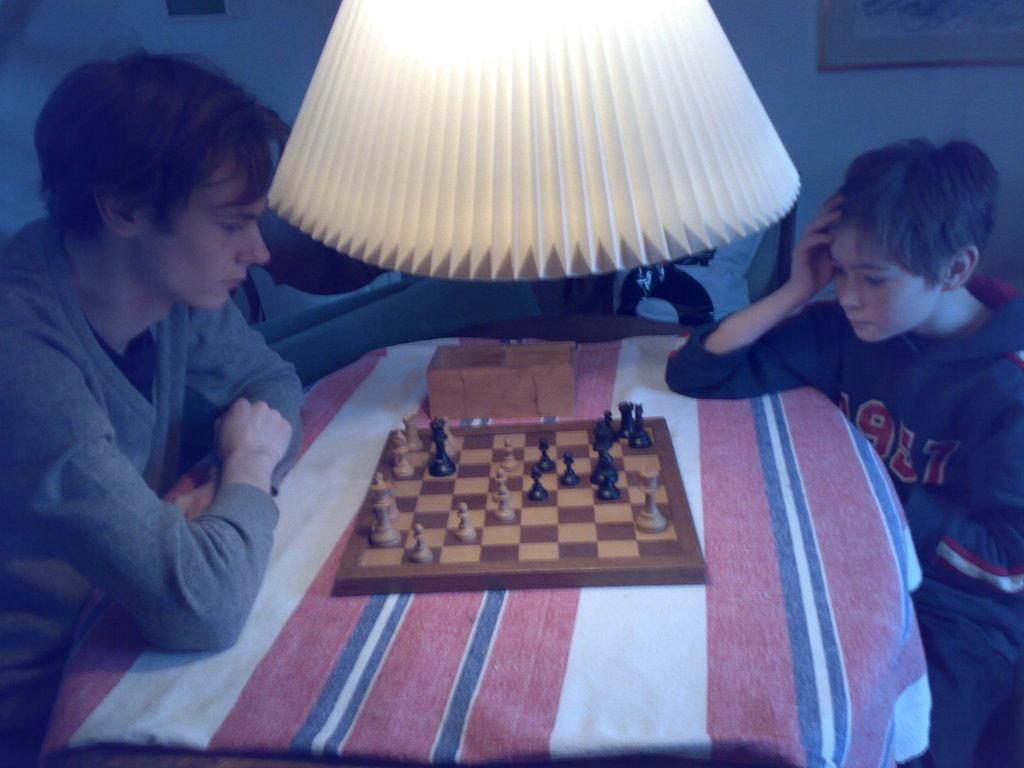How many people are in the image? There are two people in the image. What are the people doing in the image? The people are sitting on chairs. What is on the table in the image? There is a chess board, a small box, and a lamp on the table. What type of game is being played on the table? The game being played on the table is chess, as indicated by the presence of a chess board. What type of net can be seen on the ground in the image? There is no net visible on the ground in the image. 